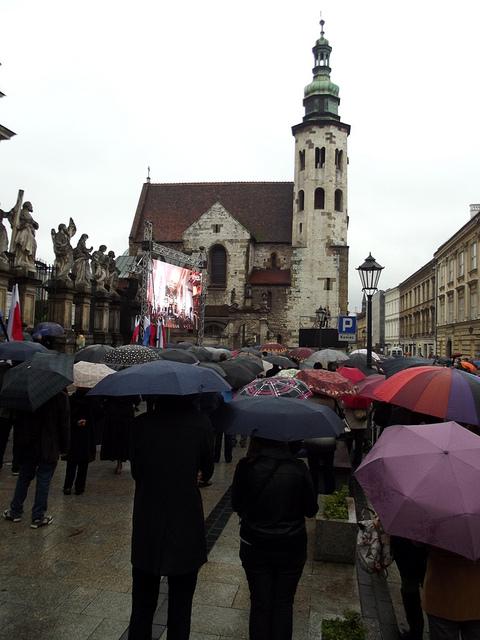What are the umbrellas for?
Write a very short answer. Rain. What color are the tables?
Keep it brief. No tables. Is it raining?
Short answer required. Yes. What is the name of the large monument in this picture?
Quick response, please. Tower. What is that building in front of them?
Keep it brief. Church. What flag is in the photo?
Answer briefly. France. What is everyone holding?
Short answer required. Umbrellas. 